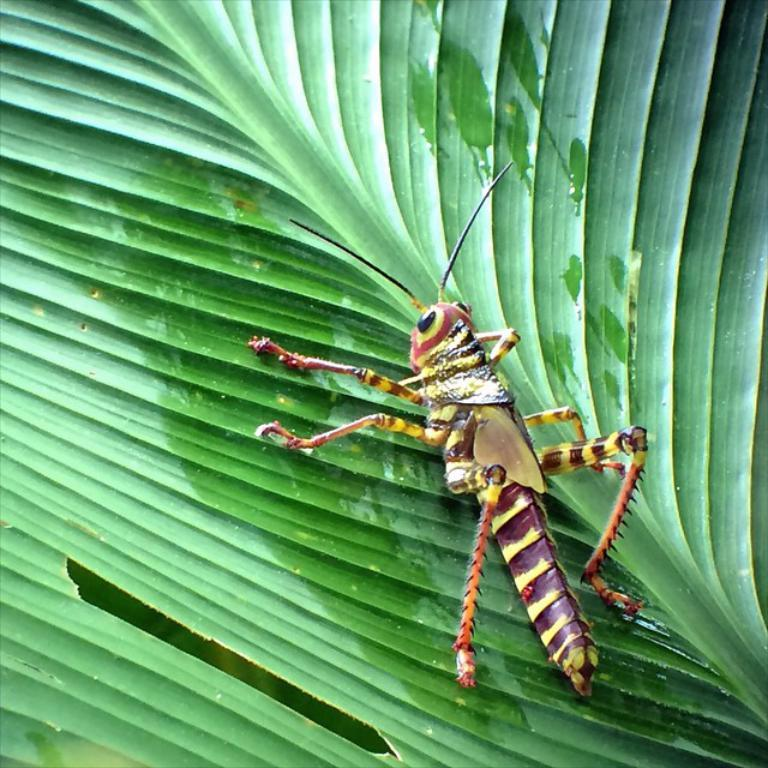What is present on the green leaf in the image? There is an insect on the green leaf in the image. Can you describe the insect's location on the leaf? The insect is on the green leaf in the image. What type of event is happening on the rod in the image? There is no rod or event present in the image; it features an insect on a green leaf. 